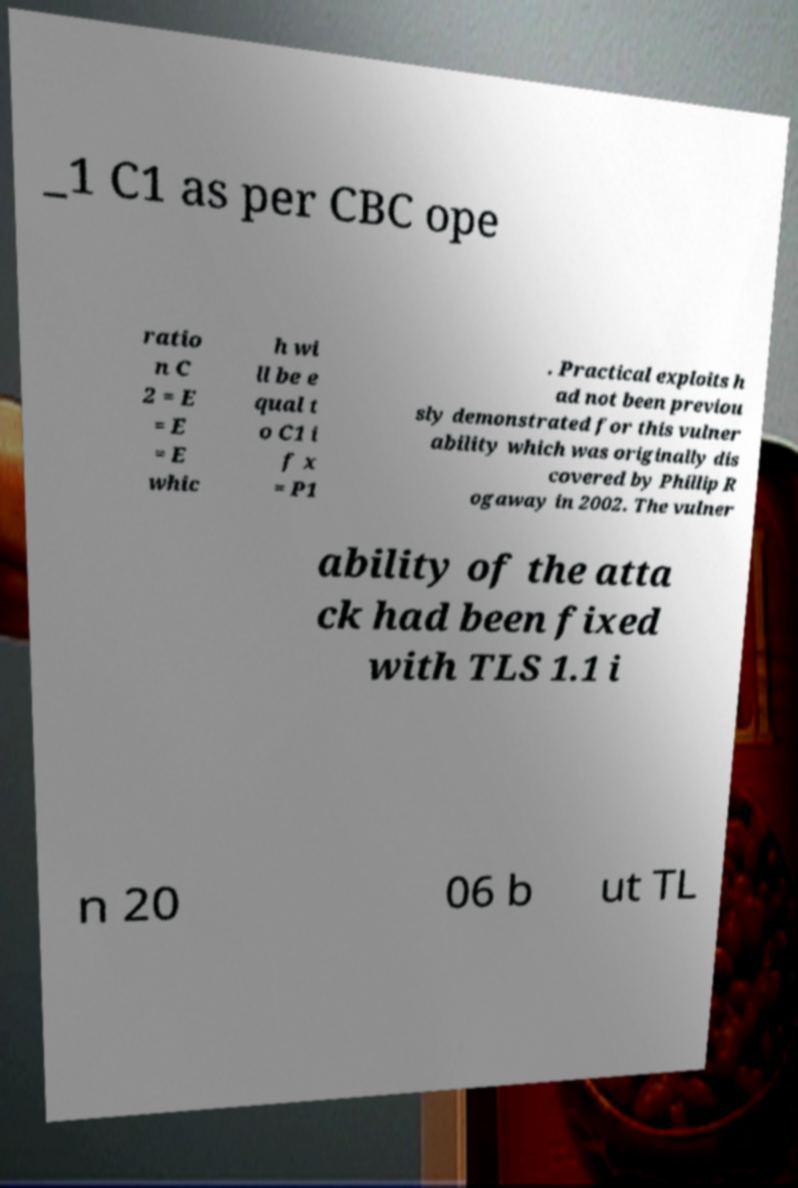There's text embedded in this image that I need extracted. Can you transcribe it verbatim? _1 C1 as per CBC ope ratio n C 2 = E = E = E whic h wi ll be e qual t o C1 i f x = P1 . Practical exploits h ad not been previou sly demonstrated for this vulner ability which was originally dis covered by Phillip R ogaway in 2002. The vulner ability of the atta ck had been fixed with TLS 1.1 i n 20 06 b ut TL 